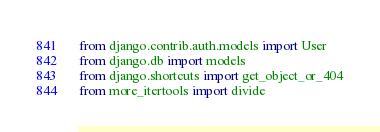Convert code to text. <code><loc_0><loc_0><loc_500><loc_500><_Python_>from django.contrib.auth.models import User
from django.db import models
from django.shortcuts import get_object_or_404
from more_itertools import divide

</code> 